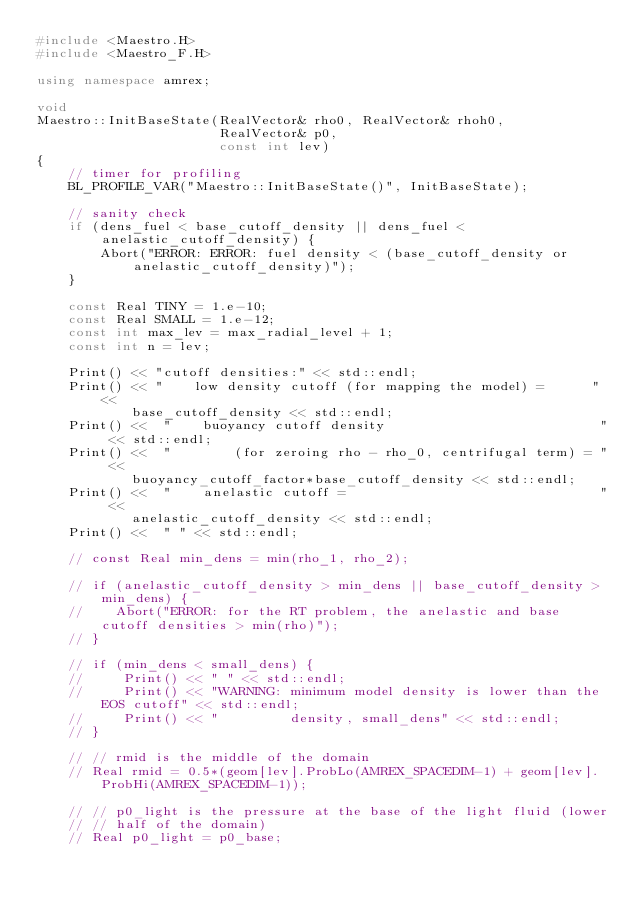Convert code to text. <code><loc_0><loc_0><loc_500><loc_500><_C++_>#include <Maestro.H>
#include <Maestro_F.H>

using namespace amrex;

void 
Maestro::InitBaseState(RealVector& rho0, RealVector& rhoh0, 
                       RealVector& p0, 
                       const int lev)
{
    // timer for profiling
    BL_PROFILE_VAR("Maestro::InitBaseState()", InitBaseState); 

    // sanity check
    if (dens_fuel < base_cutoff_density || dens_fuel < anelastic_cutoff_density) {
        Abort("ERROR: ERROR: fuel density < (base_cutoff_density or anelastic_cutoff_density)");
    }

    const Real TINY = 1.e-10;
    const Real SMALL = 1.e-12;
    const int max_lev = max_radial_level + 1;
    const int n = lev;

    Print() << "cutoff densities:" << std::endl;
    Print() << "    low density cutoff (for mapping the model) =      " << 
            base_cutoff_density << std::endl;
    Print() <<  "    buoyancy cutoff density                           " << std::endl;
    Print() <<  "        (for zeroing rho - rho_0, centrifugal term) = " << 
            buoyancy_cutoff_factor*base_cutoff_density << std::endl;
    Print() <<  "    anelastic cutoff =                                " << 
            anelastic_cutoff_density << std::endl;
    Print() <<  " " << std::endl;

    // const Real min_dens = min(rho_1, rho_2);

    // if (anelastic_cutoff_density > min_dens || base_cutoff_density > min_dens) {
    //    Abort("ERROR: for the RT problem, the anelastic and base cutoff densities > min(rho)");
    // }

    // if (min_dens < small_dens) {
    //     Print() << " " << std::endl;
    //     Print() << "WARNING: minimum model density is lower than the EOS cutoff" << std::endl;
    //     Print() << "         density, small_dens" << std::endl;
    // }

    // // rmid is the middle of the domain
    // Real rmid = 0.5*(geom[lev].ProbLo(AMREX_SPACEDIM-1) + geom[lev].ProbHi(AMREX_SPACEDIM-1));

    // // p0_light is the pressure at the base of the light fluid (lower
    // // half of the domain)
    // Real p0_light = p0_base;
</code> 